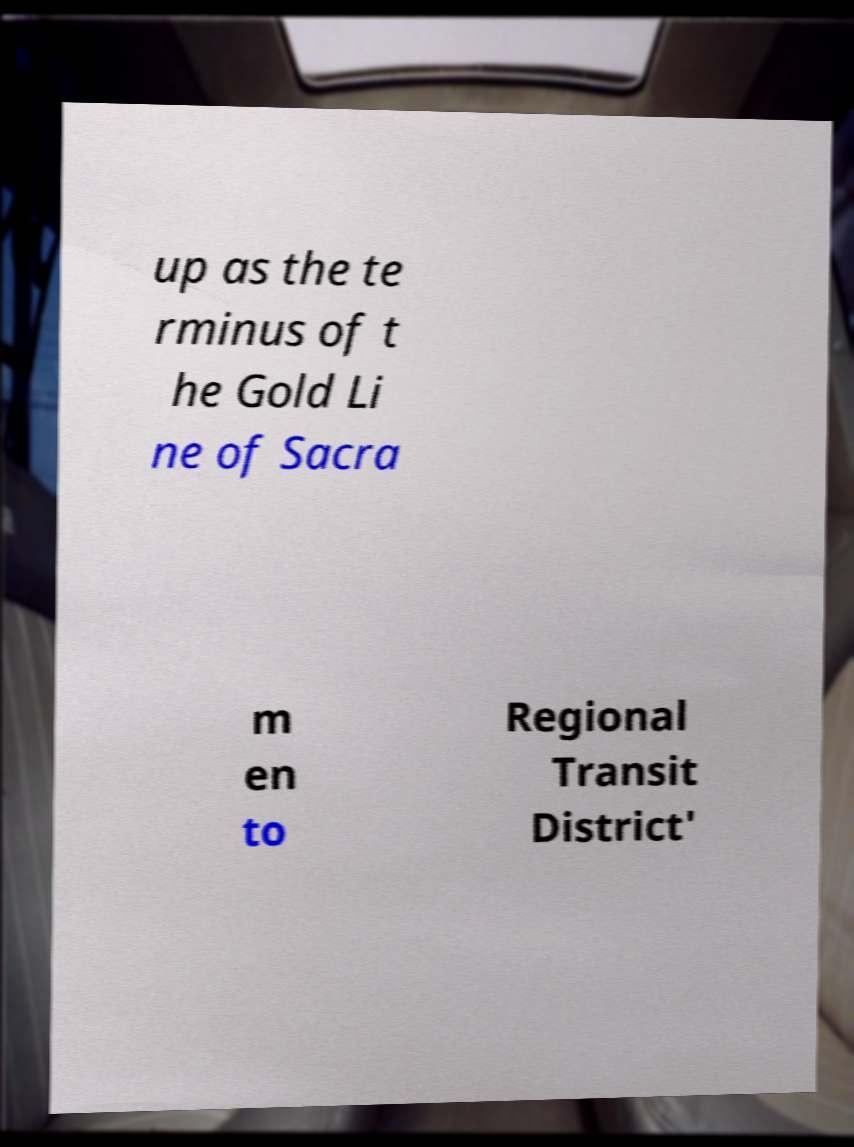I need the written content from this picture converted into text. Can you do that? up as the te rminus of t he Gold Li ne of Sacra m en to Regional Transit District' 